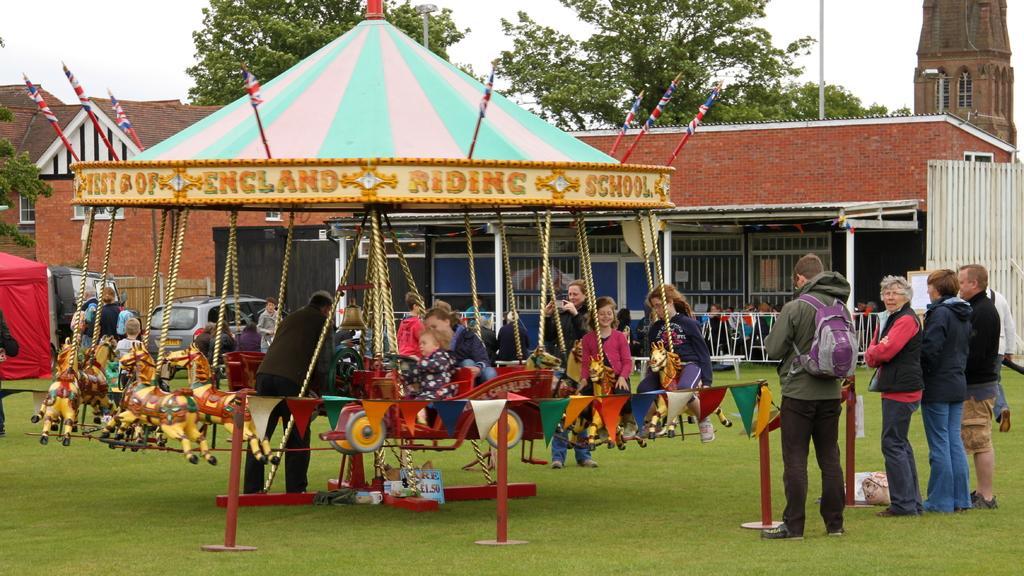Could you give a brief overview of what you see in this image? In this image, we can see a merry-go-round few few people on the grass. Right side of the image, we can see few people are standing. Here a person is wearing a backpack. Background we can see houses, tower, trees, vehicle and sky. 